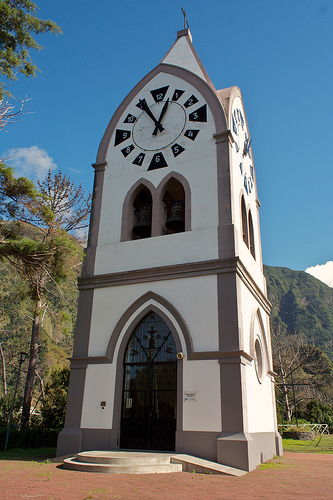What is that tower in front of? The tower is in front of a green hill. 